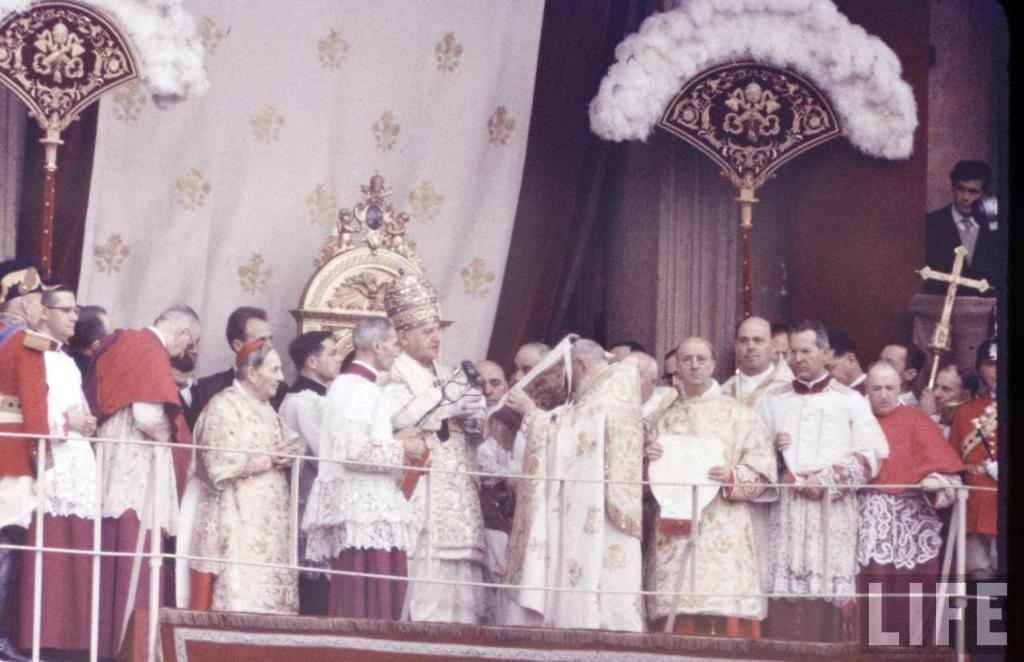Could you give a brief overview of what you see in this image? In this image, there are some persons standing and wearing clothes. There is a hand fan in the top left and in the top right of the image. There is a person on the top right of the image holding a cross with his hand. 